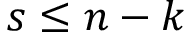Convert formula to latex. <formula><loc_0><loc_0><loc_500><loc_500>s \leq n - k</formula> 